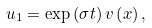Convert formula to latex. <formula><loc_0><loc_0><loc_500><loc_500>u _ { 1 } = \exp \left ( \sigma t \right ) v \left ( x \right ) ,</formula> 